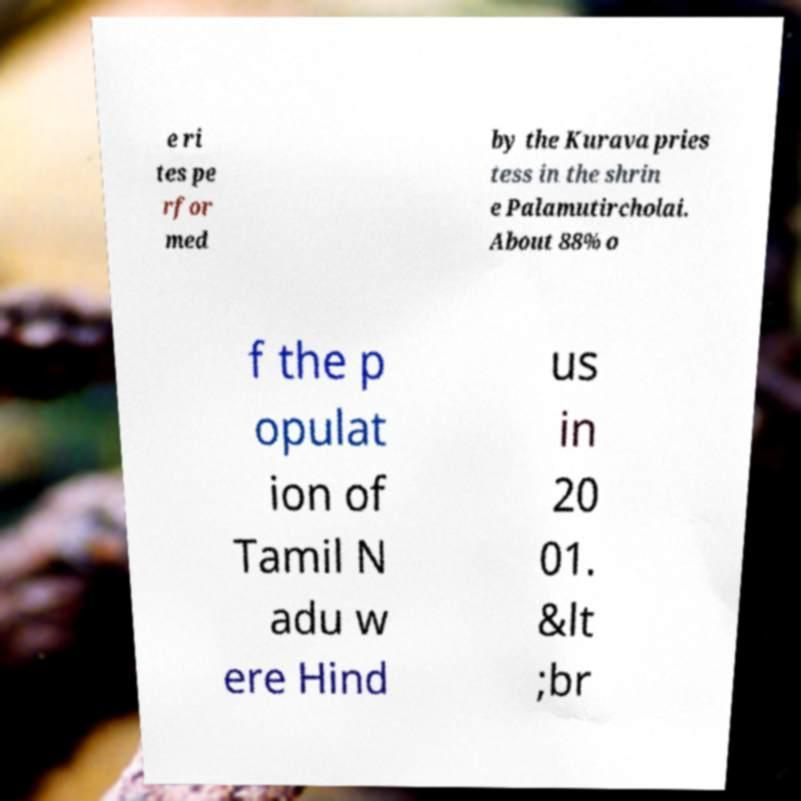What messages or text are displayed in this image? I need them in a readable, typed format. e ri tes pe rfor med by the Kurava pries tess in the shrin e Palamutircholai. About 88% o f the p opulat ion of Tamil N adu w ere Hind us in 20 01. &lt ;br 